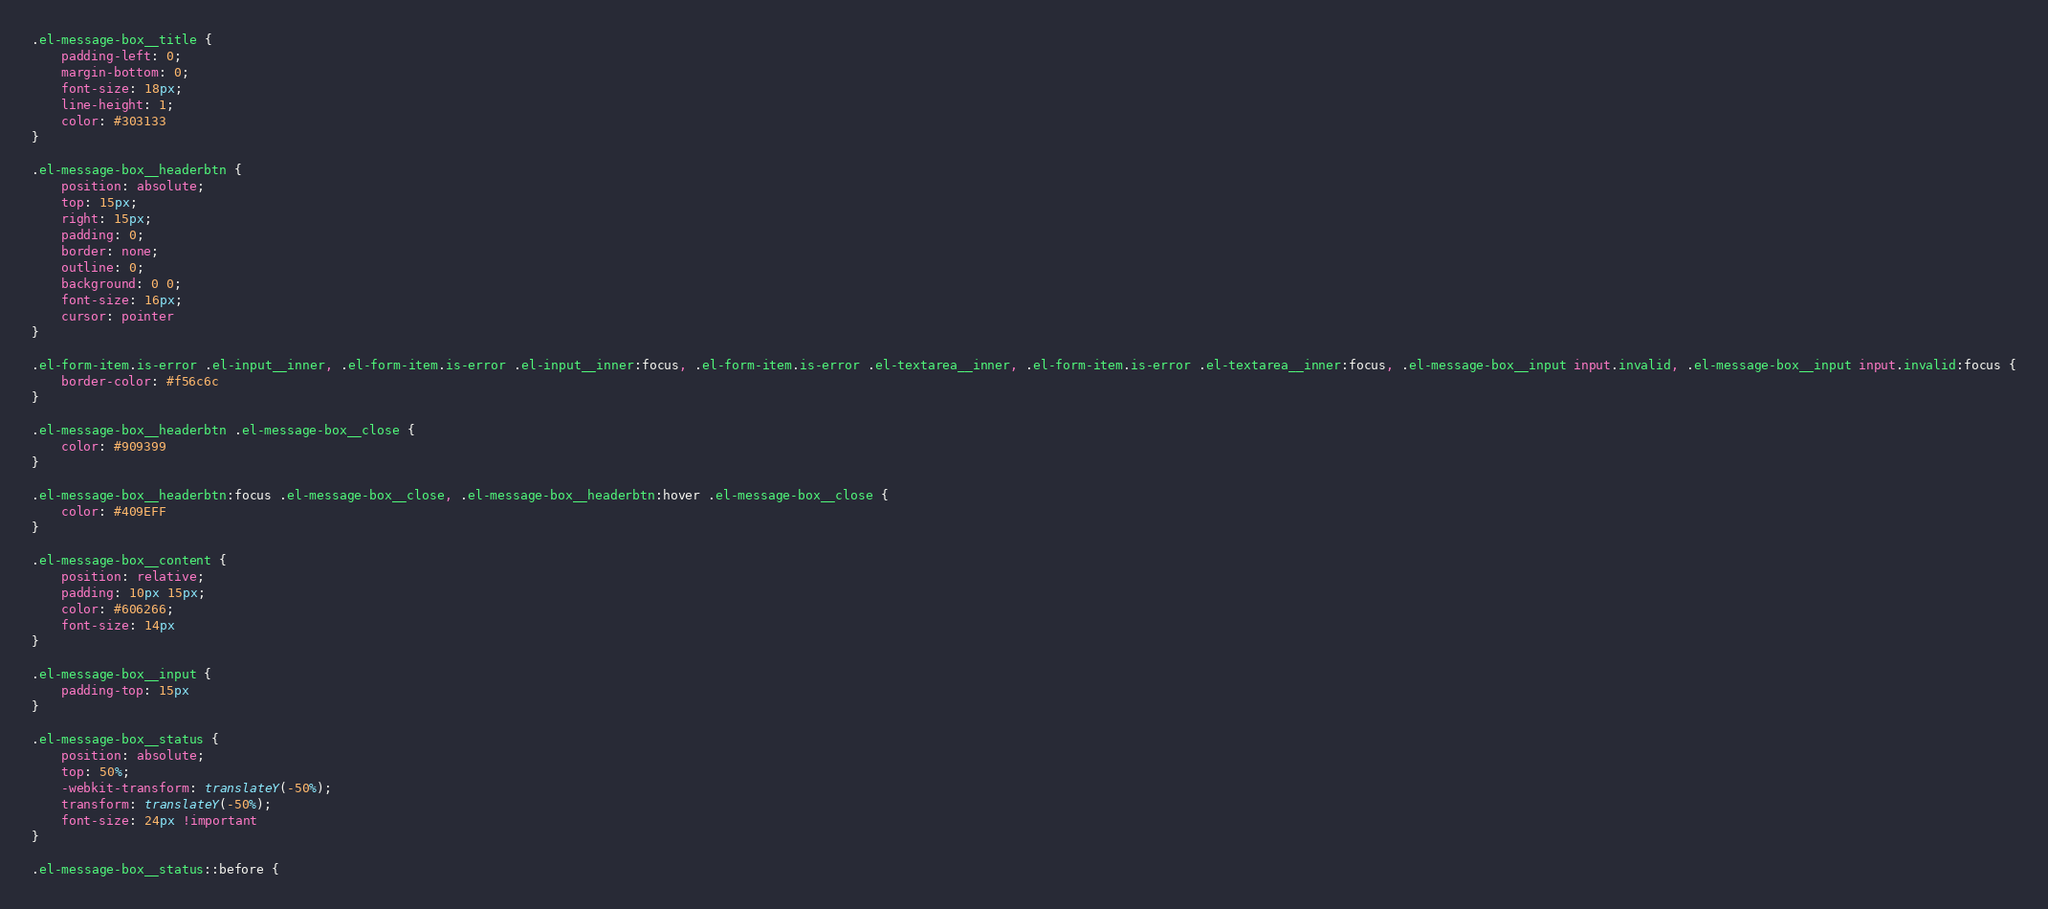Convert code to text. <code><loc_0><loc_0><loc_500><loc_500><_CSS_>.el-message-box__title {
    padding-left: 0;
    margin-bottom: 0;
    font-size: 18px;
    line-height: 1;
    color: #303133
}

.el-message-box__headerbtn {
    position: absolute;
    top: 15px;
    right: 15px;
    padding: 0;
    border: none;
    outline: 0;
    background: 0 0;
    font-size: 16px;
    cursor: pointer
}

.el-form-item.is-error .el-input__inner, .el-form-item.is-error .el-input__inner:focus, .el-form-item.is-error .el-textarea__inner, .el-form-item.is-error .el-textarea__inner:focus, .el-message-box__input input.invalid, .el-message-box__input input.invalid:focus {
    border-color: #f56c6c
}

.el-message-box__headerbtn .el-message-box__close {
    color: #909399
}

.el-message-box__headerbtn:focus .el-message-box__close, .el-message-box__headerbtn:hover .el-message-box__close {
    color: #409EFF
}

.el-message-box__content {
    position: relative;
    padding: 10px 15px;
    color: #606266;
    font-size: 14px
}

.el-message-box__input {
    padding-top: 15px
}

.el-message-box__status {
    position: absolute;
    top: 50%;
    -webkit-transform: translateY(-50%);
    transform: translateY(-50%);
    font-size: 24px !important
}

.el-message-box__status::before {</code> 